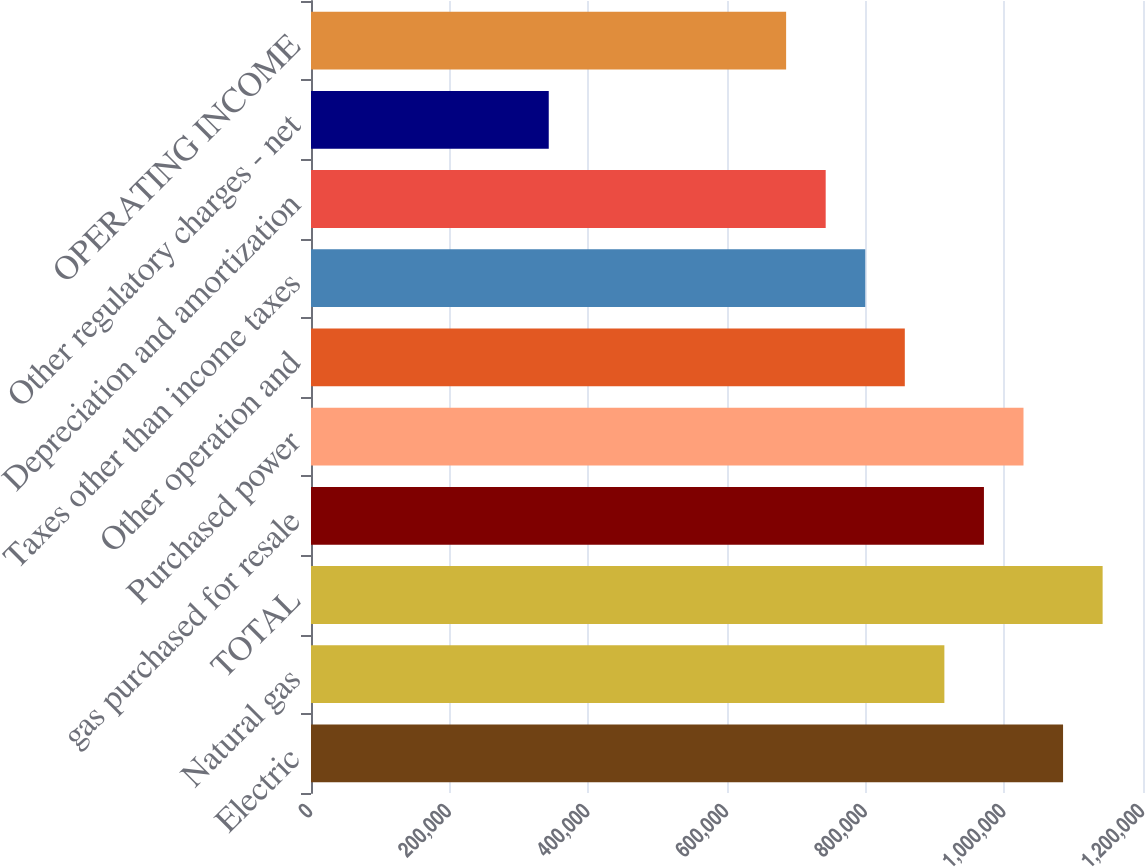Convert chart to OTSL. <chart><loc_0><loc_0><loc_500><loc_500><bar_chart><fcel>Electric<fcel>Natural gas<fcel>TOTAL<fcel>gas purchased for resale<fcel>Purchased power<fcel>Other operation and<fcel>Taxes other than income taxes<fcel>Depreciation and amortization<fcel>Other regulatory charges - net<fcel>OPERATING INCOME<nl><fcel>1.0847e+06<fcel>913521<fcel>1.14176e+06<fcel>970582<fcel>1.02764e+06<fcel>856460<fcel>799398<fcel>742337<fcel>342910<fcel>685276<nl></chart> 